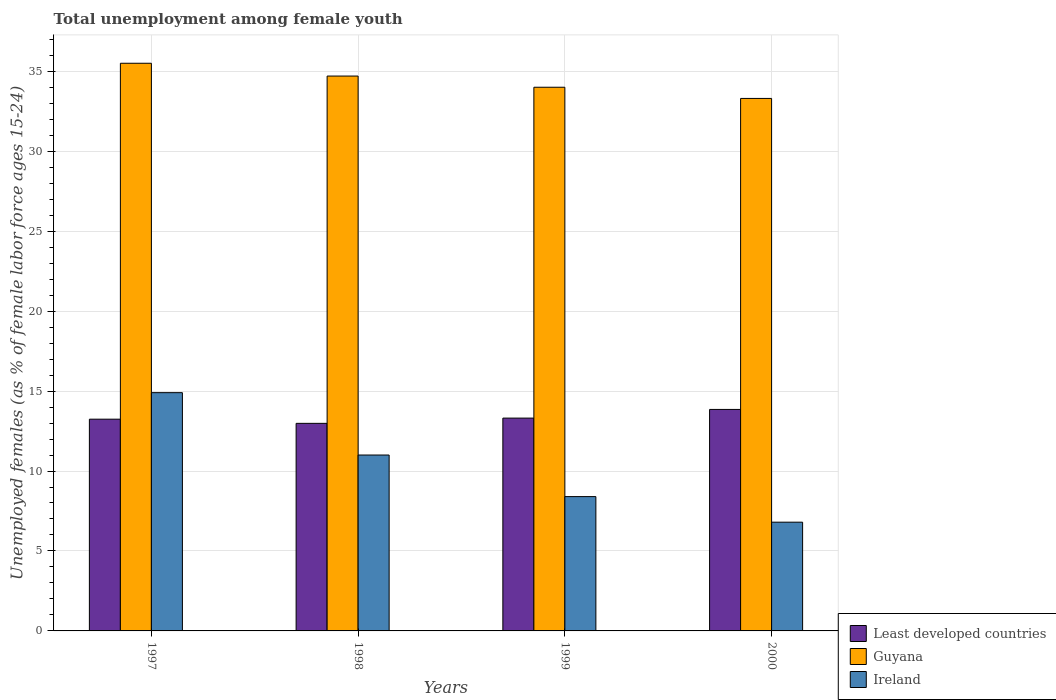How many different coloured bars are there?
Your answer should be compact. 3. How many groups of bars are there?
Provide a short and direct response. 4. What is the label of the 4th group of bars from the left?
Your answer should be very brief. 2000. In how many cases, is the number of bars for a given year not equal to the number of legend labels?
Provide a short and direct response. 0. What is the percentage of unemployed females in in Guyana in 1999?
Ensure brevity in your answer.  34. Across all years, what is the maximum percentage of unemployed females in in Guyana?
Offer a terse response. 35.5. Across all years, what is the minimum percentage of unemployed females in in Least developed countries?
Ensure brevity in your answer.  12.98. What is the total percentage of unemployed females in in Guyana in the graph?
Keep it short and to the point. 137.5. What is the difference between the percentage of unemployed females in in Ireland in 1998 and that in 2000?
Offer a very short reply. 4.2. What is the difference between the percentage of unemployed females in in Least developed countries in 1997 and the percentage of unemployed females in in Ireland in 1998?
Your response must be concise. 2.24. What is the average percentage of unemployed females in in Guyana per year?
Give a very brief answer. 34.38. In the year 1999, what is the difference between the percentage of unemployed females in in Guyana and percentage of unemployed females in in Ireland?
Provide a short and direct response. 25.6. In how many years, is the percentage of unemployed females in in Guyana greater than 11 %?
Offer a terse response. 4. What is the ratio of the percentage of unemployed females in in Ireland in 1998 to that in 2000?
Your response must be concise. 1.62. Is the difference between the percentage of unemployed females in in Guyana in 1997 and 1998 greater than the difference between the percentage of unemployed females in in Ireland in 1997 and 1998?
Offer a very short reply. No. What is the difference between the highest and the second highest percentage of unemployed females in in Ireland?
Make the answer very short. 3.9. What is the difference between the highest and the lowest percentage of unemployed females in in Guyana?
Provide a succinct answer. 2.2. In how many years, is the percentage of unemployed females in in Least developed countries greater than the average percentage of unemployed females in in Least developed countries taken over all years?
Keep it short and to the point. 1. What does the 3rd bar from the left in 1998 represents?
Ensure brevity in your answer.  Ireland. What does the 1st bar from the right in 1998 represents?
Ensure brevity in your answer.  Ireland. How many bars are there?
Give a very brief answer. 12. Where does the legend appear in the graph?
Your answer should be very brief. Bottom right. How many legend labels are there?
Keep it short and to the point. 3. What is the title of the graph?
Ensure brevity in your answer.  Total unemployment among female youth. What is the label or title of the X-axis?
Your response must be concise. Years. What is the label or title of the Y-axis?
Give a very brief answer. Unemployed females (as % of female labor force ages 15-24). What is the Unemployed females (as % of female labor force ages 15-24) of Least developed countries in 1997?
Your answer should be compact. 13.24. What is the Unemployed females (as % of female labor force ages 15-24) in Guyana in 1997?
Keep it short and to the point. 35.5. What is the Unemployed females (as % of female labor force ages 15-24) in Ireland in 1997?
Provide a short and direct response. 14.9. What is the Unemployed females (as % of female labor force ages 15-24) of Least developed countries in 1998?
Your response must be concise. 12.98. What is the Unemployed females (as % of female labor force ages 15-24) of Guyana in 1998?
Ensure brevity in your answer.  34.7. What is the Unemployed females (as % of female labor force ages 15-24) in Least developed countries in 1999?
Make the answer very short. 13.31. What is the Unemployed females (as % of female labor force ages 15-24) of Guyana in 1999?
Your answer should be compact. 34. What is the Unemployed females (as % of female labor force ages 15-24) of Ireland in 1999?
Keep it short and to the point. 8.4. What is the Unemployed females (as % of female labor force ages 15-24) of Least developed countries in 2000?
Provide a short and direct response. 13.85. What is the Unemployed females (as % of female labor force ages 15-24) of Guyana in 2000?
Provide a succinct answer. 33.3. What is the Unemployed females (as % of female labor force ages 15-24) in Ireland in 2000?
Your answer should be very brief. 6.8. Across all years, what is the maximum Unemployed females (as % of female labor force ages 15-24) of Least developed countries?
Your answer should be compact. 13.85. Across all years, what is the maximum Unemployed females (as % of female labor force ages 15-24) in Guyana?
Your answer should be very brief. 35.5. Across all years, what is the maximum Unemployed females (as % of female labor force ages 15-24) of Ireland?
Your answer should be very brief. 14.9. Across all years, what is the minimum Unemployed females (as % of female labor force ages 15-24) in Least developed countries?
Offer a very short reply. 12.98. Across all years, what is the minimum Unemployed females (as % of female labor force ages 15-24) of Guyana?
Offer a terse response. 33.3. Across all years, what is the minimum Unemployed females (as % of female labor force ages 15-24) of Ireland?
Your answer should be compact. 6.8. What is the total Unemployed females (as % of female labor force ages 15-24) of Least developed countries in the graph?
Your answer should be compact. 53.38. What is the total Unemployed females (as % of female labor force ages 15-24) of Guyana in the graph?
Ensure brevity in your answer.  137.5. What is the total Unemployed females (as % of female labor force ages 15-24) in Ireland in the graph?
Your answer should be compact. 41.1. What is the difference between the Unemployed females (as % of female labor force ages 15-24) of Least developed countries in 1997 and that in 1998?
Provide a short and direct response. 0.26. What is the difference between the Unemployed females (as % of female labor force ages 15-24) in Guyana in 1997 and that in 1998?
Your answer should be compact. 0.8. What is the difference between the Unemployed females (as % of female labor force ages 15-24) of Least developed countries in 1997 and that in 1999?
Ensure brevity in your answer.  -0.07. What is the difference between the Unemployed females (as % of female labor force ages 15-24) in Ireland in 1997 and that in 1999?
Keep it short and to the point. 6.5. What is the difference between the Unemployed females (as % of female labor force ages 15-24) in Least developed countries in 1997 and that in 2000?
Your response must be concise. -0.61. What is the difference between the Unemployed females (as % of female labor force ages 15-24) of Least developed countries in 1998 and that in 1999?
Your response must be concise. -0.33. What is the difference between the Unemployed females (as % of female labor force ages 15-24) in Guyana in 1998 and that in 1999?
Offer a terse response. 0.7. What is the difference between the Unemployed females (as % of female labor force ages 15-24) of Ireland in 1998 and that in 1999?
Ensure brevity in your answer.  2.6. What is the difference between the Unemployed females (as % of female labor force ages 15-24) in Least developed countries in 1998 and that in 2000?
Offer a very short reply. -0.87. What is the difference between the Unemployed females (as % of female labor force ages 15-24) in Guyana in 1998 and that in 2000?
Offer a very short reply. 1.4. What is the difference between the Unemployed females (as % of female labor force ages 15-24) in Ireland in 1998 and that in 2000?
Your answer should be very brief. 4.2. What is the difference between the Unemployed females (as % of female labor force ages 15-24) of Least developed countries in 1999 and that in 2000?
Provide a short and direct response. -0.54. What is the difference between the Unemployed females (as % of female labor force ages 15-24) in Guyana in 1999 and that in 2000?
Ensure brevity in your answer.  0.7. What is the difference between the Unemployed females (as % of female labor force ages 15-24) in Least developed countries in 1997 and the Unemployed females (as % of female labor force ages 15-24) in Guyana in 1998?
Your answer should be compact. -21.46. What is the difference between the Unemployed females (as % of female labor force ages 15-24) in Least developed countries in 1997 and the Unemployed females (as % of female labor force ages 15-24) in Ireland in 1998?
Your response must be concise. 2.24. What is the difference between the Unemployed females (as % of female labor force ages 15-24) of Least developed countries in 1997 and the Unemployed females (as % of female labor force ages 15-24) of Guyana in 1999?
Provide a succinct answer. -20.76. What is the difference between the Unemployed females (as % of female labor force ages 15-24) of Least developed countries in 1997 and the Unemployed females (as % of female labor force ages 15-24) of Ireland in 1999?
Keep it short and to the point. 4.84. What is the difference between the Unemployed females (as % of female labor force ages 15-24) in Guyana in 1997 and the Unemployed females (as % of female labor force ages 15-24) in Ireland in 1999?
Your answer should be compact. 27.1. What is the difference between the Unemployed females (as % of female labor force ages 15-24) of Least developed countries in 1997 and the Unemployed females (as % of female labor force ages 15-24) of Guyana in 2000?
Your answer should be compact. -20.06. What is the difference between the Unemployed females (as % of female labor force ages 15-24) of Least developed countries in 1997 and the Unemployed females (as % of female labor force ages 15-24) of Ireland in 2000?
Make the answer very short. 6.44. What is the difference between the Unemployed females (as % of female labor force ages 15-24) of Guyana in 1997 and the Unemployed females (as % of female labor force ages 15-24) of Ireland in 2000?
Give a very brief answer. 28.7. What is the difference between the Unemployed females (as % of female labor force ages 15-24) in Least developed countries in 1998 and the Unemployed females (as % of female labor force ages 15-24) in Guyana in 1999?
Your answer should be very brief. -21.02. What is the difference between the Unemployed females (as % of female labor force ages 15-24) of Least developed countries in 1998 and the Unemployed females (as % of female labor force ages 15-24) of Ireland in 1999?
Provide a short and direct response. 4.58. What is the difference between the Unemployed females (as % of female labor force ages 15-24) in Guyana in 1998 and the Unemployed females (as % of female labor force ages 15-24) in Ireland in 1999?
Ensure brevity in your answer.  26.3. What is the difference between the Unemployed females (as % of female labor force ages 15-24) in Least developed countries in 1998 and the Unemployed females (as % of female labor force ages 15-24) in Guyana in 2000?
Provide a succinct answer. -20.32. What is the difference between the Unemployed females (as % of female labor force ages 15-24) in Least developed countries in 1998 and the Unemployed females (as % of female labor force ages 15-24) in Ireland in 2000?
Your answer should be compact. 6.18. What is the difference between the Unemployed females (as % of female labor force ages 15-24) in Guyana in 1998 and the Unemployed females (as % of female labor force ages 15-24) in Ireland in 2000?
Your answer should be very brief. 27.9. What is the difference between the Unemployed females (as % of female labor force ages 15-24) of Least developed countries in 1999 and the Unemployed females (as % of female labor force ages 15-24) of Guyana in 2000?
Your answer should be compact. -19.99. What is the difference between the Unemployed females (as % of female labor force ages 15-24) in Least developed countries in 1999 and the Unemployed females (as % of female labor force ages 15-24) in Ireland in 2000?
Offer a very short reply. 6.51. What is the difference between the Unemployed females (as % of female labor force ages 15-24) of Guyana in 1999 and the Unemployed females (as % of female labor force ages 15-24) of Ireland in 2000?
Your answer should be very brief. 27.2. What is the average Unemployed females (as % of female labor force ages 15-24) of Least developed countries per year?
Your answer should be very brief. 13.35. What is the average Unemployed females (as % of female labor force ages 15-24) in Guyana per year?
Provide a short and direct response. 34.38. What is the average Unemployed females (as % of female labor force ages 15-24) in Ireland per year?
Give a very brief answer. 10.28. In the year 1997, what is the difference between the Unemployed females (as % of female labor force ages 15-24) in Least developed countries and Unemployed females (as % of female labor force ages 15-24) in Guyana?
Provide a short and direct response. -22.26. In the year 1997, what is the difference between the Unemployed females (as % of female labor force ages 15-24) of Least developed countries and Unemployed females (as % of female labor force ages 15-24) of Ireland?
Provide a succinct answer. -1.66. In the year 1997, what is the difference between the Unemployed females (as % of female labor force ages 15-24) of Guyana and Unemployed females (as % of female labor force ages 15-24) of Ireland?
Provide a succinct answer. 20.6. In the year 1998, what is the difference between the Unemployed females (as % of female labor force ages 15-24) of Least developed countries and Unemployed females (as % of female labor force ages 15-24) of Guyana?
Ensure brevity in your answer.  -21.72. In the year 1998, what is the difference between the Unemployed females (as % of female labor force ages 15-24) of Least developed countries and Unemployed females (as % of female labor force ages 15-24) of Ireland?
Your answer should be very brief. 1.98. In the year 1998, what is the difference between the Unemployed females (as % of female labor force ages 15-24) of Guyana and Unemployed females (as % of female labor force ages 15-24) of Ireland?
Provide a short and direct response. 23.7. In the year 1999, what is the difference between the Unemployed females (as % of female labor force ages 15-24) of Least developed countries and Unemployed females (as % of female labor force ages 15-24) of Guyana?
Give a very brief answer. -20.69. In the year 1999, what is the difference between the Unemployed females (as % of female labor force ages 15-24) of Least developed countries and Unemployed females (as % of female labor force ages 15-24) of Ireland?
Keep it short and to the point. 4.91. In the year 1999, what is the difference between the Unemployed females (as % of female labor force ages 15-24) in Guyana and Unemployed females (as % of female labor force ages 15-24) in Ireland?
Make the answer very short. 25.6. In the year 2000, what is the difference between the Unemployed females (as % of female labor force ages 15-24) of Least developed countries and Unemployed females (as % of female labor force ages 15-24) of Guyana?
Your answer should be very brief. -19.45. In the year 2000, what is the difference between the Unemployed females (as % of female labor force ages 15-24) of Least developed countries and Unemployed females (as % of female labor force ages 15-24) of Ireland?
Offer a terse response. 7.05. What is the ratio of the Unemployed females (as % of female labor force ages 15-24) in Least developed countries in 1997 to that in 1998?
Provide a succinct answer. 1.02. What is the ratio of the Unemployed females (as % of female labor force ages 15-24) of Guyana in 1997 to that in 1998?
Make the answer very short. 1.02. What is the ratio of the Unemployed females (as % of female labor force ages 15-24) of Ireland in 1997 to that in 1998?
Keep it short and to the point. 1.35. What is the ratio of the Unemployed females (as % of female labor force ages 15-24) in Least developed countries in 1997 to that in 1999?
Your answer should be compact. 0.99. What is the ratio of the Unemployed females (as % of female labor force ages 15-24) in Guyana in 1997 to that in 1999?
Keep it short and to the point. 1.04. What is the ratio of the Unemployed females (as % of female labor force ages 15-24) of Ireland in 1997 to that in 1999?
Offer a very short reply. 1.77. What is the ratio of the Unemployed females (as % of female labor force ages 15-24) in Least developed countries in 1997 to that in 2000?
Ensure brevity in your answer.  0.96. What is the ratio of the Unemployed females (as % of female labor force ages 15-24) in Guyana in 1997 to that in 2000?
Provide a short and direct response. 1.07. What is the ratio of the Unemployed females (as % of female labor force ages 15-24) of Ireland in 1997 to that in 2000?
Make the answer very short. 2.19. What is the ratio of the Unemployed females (as % of female labor force ages 15-24) of Least developed countries in 1998 to that in 1999?
Keep it short and to the point. 0.98. What is the ratio of the Unemployed females (as % of female labor force ages 15-24) in Guyana in 1998 to that in 1999?
Your answer should be compact. 1.02. What is the ratio of the Unemployed females (as % of female labor force ages 15-24) in Ireland in 1998 to that in 1999?
Offer a very short reply. 1.31. What is the ratio of the Unemployed females (as % of female labor force ages 15-24) of Least developed countries in 1998 to that in 2000?
Make the answer very short. 0.94. What is the ratio of the Unemployed females (as % of female labor force ages 15-24) in Guyana in 1998 to that in 2000?
Provide a succinct answer. 1.04. What is the ratio of the Unemployed females (as % of female labor force ages 15-24) of Ireland in 1998 to that in 2000?
Keep it short and to the point. 1.62. What is the ratio of the Unemployed females (as % of female labor force ages 15-24) of Least developed countries in 1999 to that in 2000?
Your response must be concise. 0.96. What is the ratio of the Unemployed females (as % of female labor force ages 15-24) in Guyana in 1999 to that in 2000?
Keep it short and to the point. 1.02. What is the ratio of the Unemployed females (as % of female labor force ages 15-24) of Ireland in 1999 to that in 2000?
Provide a short and direct response. 1.24. What is the difference between the highest and the second highest Unemployed females (as % of female labor force ages 15-24) of Least developed countries?
Your response must be concise. 0.54. What is the difference between the highest and the second highest Unemployed females (as % of female labor force ages 15-24) in Ireland?
Your answer should be compact. 3.9. What is the difference between the highest and the lowest Unemployed females (as % of female labor force ages 15-24) in Least developed countries?
Offer a terse response. 0.87. What is the difference between the highest and the lowest Unemployed females (as % of female labor force ages 15-24) in Guyana?
Keep it short and to the point. 2.2. What is the difference between the highest and the lowest Unemployed females (as % of female labor force ages 15-24) in Ireland?
Your answer should be compact. 8.1. 